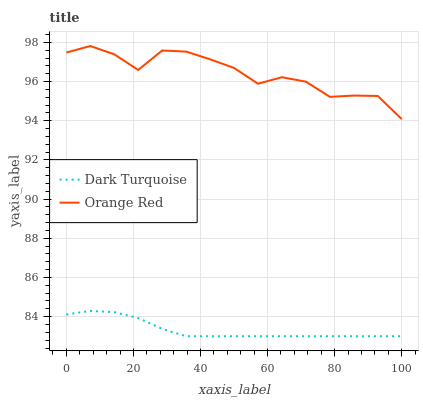Does Dark Turquoise have the minimum area under the curve?
Answer yes or no. Yes. Does Orange Red have the maximum area under the curve?
Answer yes or no. Yes. Does Orange Red have the minimum area under the curve?
Answer yes or no. No. Is Dark Turquoise the smoothest?
Answer yes or no. Yes. Is Orange Red the roughest?
Answer yes or no. Yes. Is Orange Red the smoothest?
Answer yes or no. No. Does Dark Turquoise have the lowest value?
Answer yes or no. Yes. Does Orange Red have the lowest value?
Answer yes or no. No. Does Orange Red have the highest value?
Answer yes or no. Yes. Is Dark Turquoise less than Orange Red?
Answer yes or no. Yes. Is Orange Red greater than Dark Turquoise?
Answer yes or no. Yes. Does Dark Turquoise intersect Orange Red?
Answer yes or no. No. 